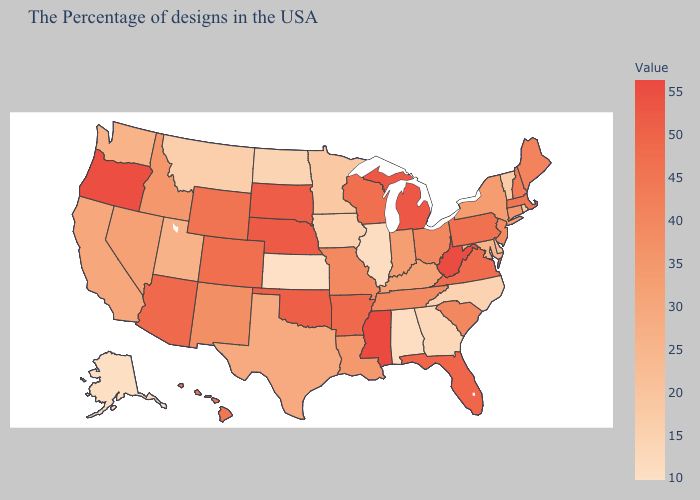Among the states that border Florida , does Georgia have the highest value?
Quick response, please. Yes. Which states have the lowest value in the South?
Keep it brief. Alabama. Which states have the highest value in the USA?
Be succinct. Mississippi. 